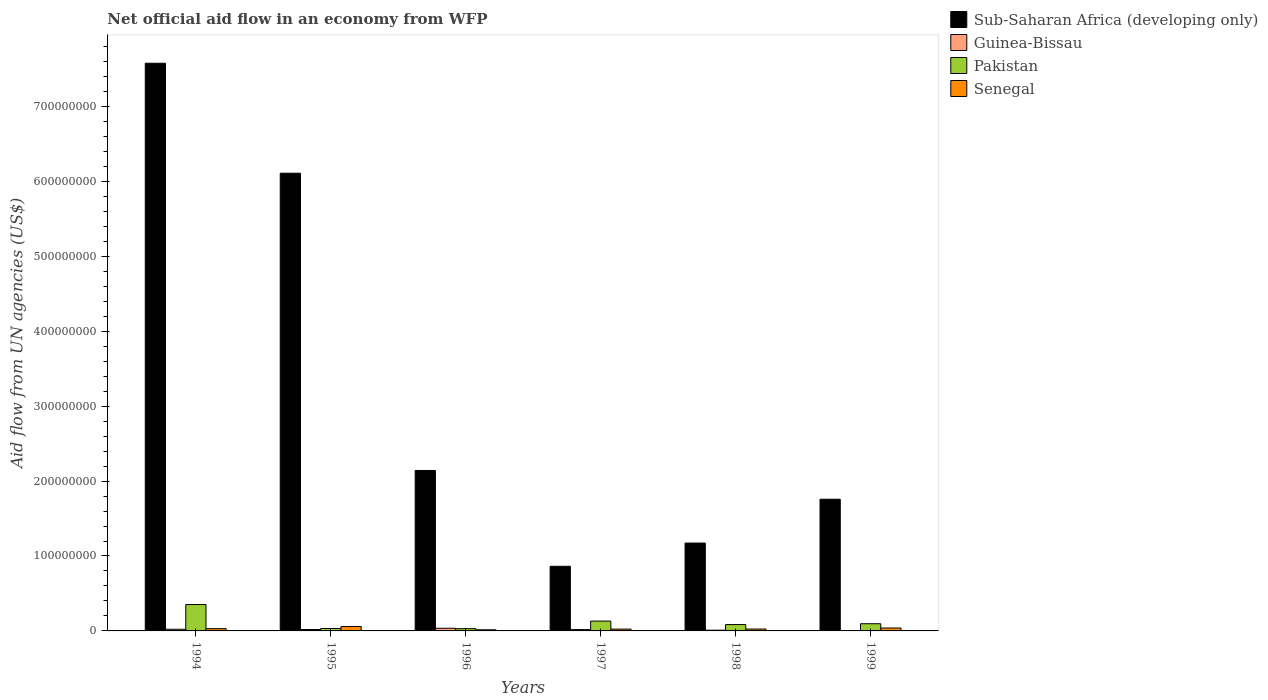How many different coloured bars are there?
Make the answer very short. 4. Are the number of bars per tick equal to the number of legend labels?
Your answer should be very brief. Yes. Are the number of bars on each tick of the X-axis equal?
Ensure brevity in your answer.  Yes. How many bars are there on the 6th tick from the right?
Keep it short and to the point. 4. In how many cases, is the number of bars for a given year not equal to the number of legend labels?
Offer a terse response. 0. What is the net official aid flow in Pakistan in 1998?
Your response must be concise. 8.47e+06. Across all years, what is the maximum net official aid flow in Senegal?
Your answer should be compact. 5.94e+06. Across all years, what is the minimum net official aid flow in Sub-Saharan Africa (developing only)?
Your answer should be compact. 8.63e+07. What is the total net official aid flow in Pakistan in the graph?
Give a very brief answer. 7.27e+07. What is the difference between the net official aid flow in Guinea-Bissau in 1996 and that in 1998?
Your response must be concise. 2.55e+06. What is the difference between the net official aid flow in Pakistan in 1999 and the net official aid flow in Senegal in 1996?
Your response must be concise. 8.10e+06. What is the average net official aid flow in Sub-Saharan Africa (developing only) per year?
Keep it short and to the point. 3.27e+08. In the year 1998, what is the difference between the net official aid flow in Guinea-Bissau and net official aid flow in Pakistan?
Ensure brevity in your answer.  -7.47e+06. In how many years, is the net official aid flow in Senegal greater than 500000000 US$?
Your response must be concise. 0. What is the ratio of the net official aid flow in Sub-Saharan Africa (developing only) in 1995 to that in 1996?
Your answer should be very brief. 2.85. Is the net official aid flow in Guinea-Bissau in 1997 less than that in 1998?
Offer a terse response. No. Is the difference between the net official aid flow in Guinea-Bissau in 1997 and 1999 greater than the difference between the net official aid flow in Pakistan in 1997 and 1999?
Ensure brevity in your answer.  No. What is the difference between the highest and the second highest net official aid flow in Pakistan?
Give a very brief answer. 2.21e+07. What is the difference between the highest and the lowest net official aid flow in Pakistan?
Make the answer very short. 3.22e+07. In how many years, is the net official aid flow in Pakistan greater than the average net official aid flow in Pakistan taken over all years?
Make the answer very short. 2. Is the sum of the net official aid flow in Sub-Saharan Africa (developing only) in 1995 and 1997 greater than the maximum net official aid flow in Senegal across all years?
Provide a succinct answer. Yes. What does the 4th bar from the left in 1995 represents?
Your response must be concise. Senegal. What does the 1st bar from the right in 1997 represents?
Ensure brevity in your answer.  Senegal. How many bars are there?
Provide a succinct answer. 24. Are the values on the major ticks of Y-axis written in scientific E-notation?
Your answer should be compact. No. How are the legend labels stacked?
Provide a short and direct response. Vertical. What is the title of the graph?
Provide a short and direct response. Net official aid flow in an economy from WFP. Does "Vanuatu" appear as one of the legend labels in the graph?
Offer a terse response. No. What is the label or title of the X-axis?
Ensure brevity in your answer.  Years. What is the label or title of the Y-axis?
Your response must be concise. Aid flow from UN agencies (US$). What is the Aid flow from UN agencies (US$) of Sub-Saharan Africa (developing only) in 1994?
Give a very brief answer. 7.58e+08. What is the Aid flow from UN agencies (US$) of Guinea-Bissau in 1994?
Provide a succinct answer. 2.22e+06. What is the Aid flow from UN agencies (US$) of Pakistan in 1994?
Provide a succinct answer. 3.52e+07. What is the Aid flow from UN agencies (US$) in Senegal in 1994?
Give a very brief answer. 3.02e+06. What is the Aid flow from UN agencies (US$) in Sub-Saharan Africa (developing only) in 1995?
Offer a terse response. 6.11e+08. What is the Aid flow from UN agencies (US$) of Guinea-Bissau in 1995?
Provide a short and direct response. 1.86e+06. What is the Aid flow from UN agencies (US$) in Pakistan in 1995?
Your answer should be compact. 3.25e+06. What is the Aid flow from UN agencies (US$) in Senegal in 1995?
Provide a succinct answer. 5.94e+06. What is the Aid flow from UN agencies (US$) in Sub-Saharan Africa (developing only) in 1996?
Your answer should be compact. 2.14e+08. What is the Aid flow from UN agencies (US$) in Guinea-Bissau in 1996?
Your answer should be very brief. 3.55e+06. What is the Aid flow from UN agencies (US$) of Pakistan in 1996?
Your response must be concise. 3.03e+06. What is the Aid flow from UN agencies (US$) of Senegal in 1996?
Offer a very short reply. 1.51e+06. What is the Aid flow from UN agencies (US$) in Sub-Saharan Africa (developing only) in 1997?
Offer a terse response. 8.63e+07. What is the Aid flow from UN agencies (US$) of Guinea-Bissau in 1997?
Provide a short and direct response. 1.79e+06. What is the Aid flow from UN agencies (US$) in Pakistan in 1997?
Provide a short and direct response. 1.31e+07. What is the Aid flow from UN agencies (US$) of Senegal in 1997?
Give a very brief answer. 2.42e+06. What is the Aid flow from UN agencies (US$) of Sub-Saharan Africa (developing only) in 1998?
Offer a terse response. 1.17e+08. What is the Aid flow from UN agencies (US$) of Guinea-Bissau in 1998?
Your answer should be compact. 1.00e+06. What is the Aid flow from UN agencies (US$) of Pakistan in 1998?
Ensure brevity in your answer.  8.47e+06. What is the Aid flow from UN agencies (US$) in Senegal in 1998?
Offer a very short reply. 2.50e+06. What is the Aid flow from UN agencies (US$) of Sub-Saharan Africa (developing only) in 1999?
Offer a terse response. 1.76e+08. What is the Aid flow from UN agencies (US$) in Guinea-Bissau in 1999?
Ensure brevity in your answer.  4.50e+05. What is the Aid flow from UN agencies (US$) in Pakistan in 1999?
Your answer should be very brief. 9.61e+06. What is the Aid flow from UN agencies (US$) in Senegal in 1999?
Provide a succinct answer. 3.88e+06. Across all years, what is the maximum Aid flow from UN agencies (US$) of Sub-Saharan Africa (developing only)?
Offer a terse response. 7.58e+08. Across all years, what is the maximum Aid flow from UN agencies (US$) in Guinea-Bissau?
Provide a succinct answer. 3.55e+06. Across all years, what is the maximum Aid flow from UN agencies (US$) in Pakistan?
Give a very brief answer. 3.52e+07. Across all years, what is the maximum Aid flow from UN agencies (US$) of Senegal?
Provide a short and direct response. 5.94e+06. Across all years, what is the minimum Aid flow from UN agencies (US$) of Sub-Saharan Africa (developing only)?
Give a very brief answer. 8.63e+07. Across all years, what is the minimum Aid flow from UN agencies (US$) of Pakistan?
Make the answer very short. 3.03e+06. Across all years, what is the minimum Aid flow from UN agencies (US$) of Senegal?
Offer a terse response. 1.51e+06. What is the total Aid flow from UN agencies (US$) in Sub-Saharan Africa (developing only) in the graph?
Your response must be concise. 1.96e+09. What is the total Aid flow from UN agencies (US$) of Guinea-Bissau in the graph?
Your answer should be compact. 1.09e+07. What is the total Aid flow from UN agencies (US$) in Pakistan in the graph?
Offer a terse response. 7.27e+07. What is the total Aid flow from UN agencies (US$) of Senegal in the graph?
Provide a succinct answer. 1.93e+07. What is the difference between the Aid flow from UN agencies (US$) in Sub-Saharan Africa (developing only) in 1994 and that in 1995?
Ensure brevity in your answer.  1.47e+08. What is the difference between the Aid flow from UN agencies (US$) in Guinea-Bissau in 1994 and that in 1995?
Your answer should be compact. 3.60e+05. What is the difference between the Aid flow from UN agencies (US$) in Pakistan in 1994 and that in 1995?
Keep it short and to the point. 3.20e+07. What is the difference between the Aid flow from UN agencies (US$) of Senegal in 1994 and that in 1995?
Offer a terse response. -2.92e+06. What is the difference between the Aid flow from UN agencies (US$) of Sub-Saharan Africa (developing only) in 1994 and that in 1996?
Your answer should be compact. 5.44e+08. What is the difference between the Aid flow from UN agencies (US$) in Guinea-Bissau in 1994 and that in 1996?
Keep it short and to the point. -1.33e+06. What is the difference between the Aid flow from UN agencies (US$) of Pakistan in 1994 and that in 1996?
Offer a terse response. 3.22e+07. What is the difference between the Aid flow from UN agencies (US$) of Senegal in 1994 and that in 1996?
Make the answer very short. 1.51e+06. What is the difference between the Aid flow from UN agencies (US$) of Sub-Saharan Africa (developing only) in 1994 and that in 1997?
Your answer should be compact. 6.71e+08. What is the difference between the Aid flow from UN agencies (US$) in Guinea-Bissau in 1994 and that in 1997?
Ensure brevity in your answer.  4.30e+05. What is the difference between the Aid flow from UN agencies (US$) in Pakistan in 1994 and that in 1997?
Keep it short and to the point. 2.21e+07. What is the difference between the Aid flow from UN agencies (US$) in Sub-Saharan Africa (developing only) in 1994 and that in 1998?
Keep it short and to the point. 6.40e+08. What is the difference between the Aid flow from UN agencies (US$) in Guinea-Bissau in 1994 and that in 1998?
Your answer should be very brief. 1.22e+06. What is the difference between the Aid flow from UN agencies (US$) of Pakistan in 1994 and that in 1998?
Ensure brevity in your answer.  2.68e+07. What is the difference between the Aid flow from UN agencies (US$) in Senegal in 1994 and that in 1998?
Ensure brevity in your answer.  5.20e+05. What is the difference between the Aid flow from UN agencies (US$) of Sub-Saharan Africa (developing only) in 1994 and that in 1999?
Ensure brevity in your answer.  5.82e+08. What is the difference between the Aid flow from UN agencies (US$) in Guinea-Bissau in 1994 and that in 1999?
Your answer should be very brief. 1.77e+06. What is the difference between the Aid flow from UN agencies (US$) in Pakistan in 1994 and that in 1999?
Provide a short and direct response. 2.56e+07. What is the difference between the Aid flow from UN agencies (US$) of Senegal in 1994 and that in 1999?
Give a very brief answer. -8.60e+05. What is the difference between the Aid flow from UN agencies (US$) of Sub-Saharan Africa (developing only) in 1995 and that in 1996?
Ensure brevity in your answer.  3.97e+08. What is the difference between the Aid flow from UN agencies (US$) in Guinea-Bissau in 1995 and that in 1996?
Make the answer very short. -1.69e+06. What is the difference between the Aid flow from UN agencies (US$) in Senegal in 1995 and that in 1996?
Keep it short and to the point. 4.43e+06. What is the difference between the Aid flow from UN agencies (US$) of Sub-Saharan Africa (developing only) in 1995 and that in 1997?
Offer a very short reply. 5.25e+08. What is the difference between the Aid flow from UN agencies (US$) in Pakistan in 1995 and that in 1997?
Offer a terse response. -9.88e+06. What is the difference between the Aid flow from UN agencies (US$) in Senegal in 1995 and that in 1997?
Your answer should be compact. 3.52e+06. What is the difference between the Aid flow from UN agencies (US$) of Sub-Saharan Africa (developing only) in 1995 and that in 1998?
Ensure brevity in your answer.  4.94e+08. What is the difference between the Aid flow from UN agencies (US$) in Guinea-Bissau in 1995 and that in 1998?
Your answer should be compact. 8.60e+05. What is the difference between the Aid flow from UN agencies (US$) of Pakistan in 1995 and that in 1998?
Make the answer very short. -5.22e+06. What is the difference between the Aid flow from UN agencies (US$) of Senegal in 1995 and that in 1998?
Keep it short and to the point. 3.44e+06. What is the difference between the Aid flow from UN agencies (US$) of Sub-Saharan Africa (developing only) in 1995 and that in 1999?
Your response must be concise. 4.35e+08. What is the difference between the Aid flow from UN agencies (US$) in Guinea-Bissau in 1995 and that in 1999?
Give a very brief answer. 1.41e+06. What is the difference between the Aid flow from UN agencies (US$) of Pakistan in 1995 and that in 1999?
Your answer should be very brief. -6.36e+06. What is the difference between the Aid flow from UN agencies (US$) in Senegal in 1995 and that in 1999?
Your answer should be very brief. 2.06e+06. What is the difference between the Aid flow from UN agencies (US$) in Sub-Saharan Africa (developing only) in 1996 and that in 1997?
Give a very brief answer. 1.28e+08. What is the difference between the Aid flow from UN agencies (US$) of Guinea-Bissau in 1996 and that in 1997?
Your answer should be very brief. 1.76e+06. What is the difference between the Aid flow from UN agencies (US$) of Pakistan in 1996 and that in 1997?
Give a very brief answer. -1.01e+07. What is the difference between the Aid flow from UN agencies (US$) in Senegal in 1996 and that in 1997?
Keep it short and to the point. -9.10e+05. What is the difference between the Aid flow from UN agencies (US$) of Sub-Saharan Africa (developing only) in 1996 and that in 1998?
Give a very brief answer. 9.69e+07. What is the difference between the Aid flow from UN agencies (US$) in Guinea-Bissau in 1996 and that in 1998?
Provide a succinct answer. 2.55e+06. What is the difference between the Aid flow from UN agencies (US$) in Pakistan in 1996 and that in 1998?
Ensure brevity in your answer.  -5.44e+06. What is the difference between the Aid flow from UN agencies (US$) in Senegal in 1996 and that in 1998?
Provide a short and direct response. -9.90e+05. What is the difference between the Aid flow from UN agencies (US$) in Sub-Saharan Africa (developing only) in 1996 and that in 1999?
Your response must be concise. 3.84e+07. What is the difference between the Aid flow from UN agencies (US$) in Guinea-Bissau in 1996 and that in 1999?
Give a very brief answer. 3.10e+06. What is the difference between the Aid flow from UN agencies (US$) of Pakistan in 1996 and that in 1999?
Your answer should be very brief. -6.58e+06. What is the difference between the Aid flow from UN agencies (US$) of Senegal in 1996 and that in 1999?
Offer a very short reply. -2.37e+06. What is the difference between the Aid flow from UN agencies (US$) in Sub-Saharan Africa (developing only) in 1997 and that in 1998?
Your answer should be very brief. -3.10e+07. What is the difference between the Aid flow from UN agencies (US$) of Guinea-Bissau in 1997 and that in 1998?
Your response must be concise. 7.90e+05. What is the difference between the Aid flow from UN agencies (US$) of Pakistan in 1997 and that in 1998?
Your answer should be very brief. 4.66e+06. What is the difference between the Aid flow from UN agencies (US$) in Sub-Saharan Africa (developing only) in 1997 and that in 1999?
Keep it short and to the point. -8.95e+07. What is the difference between the Aid flow from UN agencies (US$) in Guinea-Bissau in 1997 and that in 1999?
Your answer should be very brief. 1.34e+06. What is the difference between the Aid flow from UN agencies (US$) of Pakistan in 1997 and that in 1999?
Offer a terse response. 3.52e+06. What is the difference between the Aid flow from UN agencies (US$) in Senegal in 1997 and that in 1999?
Keep it short and to the point. -1.46e+06. What is the difference between the Aid flow from UN agencies (US$) of Sub-Saharan Africa (developing only) in 1998 and that in 1999?
Provide a short and direct response. -5.85e+07. What is the difference between the Aid flow from UN agencies (US$) in Guinea-Bissau in 1998 and that in 1999?
Your answer should be very brief. 5.50e+05. What is the difference between the Aid flow from UN agencies (US$) of Pakistan in 1998 and that in 1999?
Provide a short and direct response. -1.14e+06. What is the difference between the Aid flow from UN agencies (US$) in Senegal in 1998 and that in 1999?
Keep it short and to the point. -1.38e+06. What is the difference between the Aid flow from UN agencies (US$) in Sub-Saharan Africa (developing only) in 1994 and the Aid flow from UN agencies (US$) in Guinea-Bissau in 1995?
Ensure brevity in your answer.  7.56e+08. What is the difference between the Aid flow from UN agencies (US$) in Sub-Saharan Africa (developing only) in 1994 and the Aid flow from UN agencies (US$) in Pakistan in 1995?
Make the answer very short. 7.54e+08. What is the difference between the Aid flow from UN agencies (US$) in Sub-Saharan Africa (developing only) in 1994 and the Aid flow from UN agencies (US$) in Senegal in 1995?
Give a very brief answer. 7.52e+08. What is the difference between the Aid flow from UN agencies (US$) of Guinea-Bissau in 1994 and the Aid flow from UN agencies (US$) of Pakistan in 1995?
Offer a very short reply. -1.03e+06. What is the difference between the Aid flow from UN agencies (US$) of Guinea-Bissau in 1994 and the Aid flow from UN agencies (US$) of Senegal in 1995?
Offer a very short reply. -3.72e+06. What is the difference between the Aid flow from UN agencies (US$) of Pakistan in 1994 and the Aid flow from UN agencies (US$) of Senegal in 1995?
Provide a succinct answer. 2.93e+07. What is the difference between the Aid flow from UN agencies (US$) of Sub-Saharan Africa (developing only) in 1994 and the Aid flow from UN agencies (US$) of Guinea-Bissau in 1996?
Provide a succinct answer. 7.54e+08. What is the difference between the Aid flow from UN agencies (US$) of Sub-Saharan Africa (developing only) in 1994 and the Aid flow from UN agencies (US$) of Pakistan in 1996?
Give a very brief answer. 7.55e+08. What is the difference between the Aid flow from UN agencies (US$) of Sub-Saharan Africa (developing only) in 1994 and the Aid flow from UN agencies (US$) of Senegal in 1996?
Keep it short and to the point. 7.56e+08. What is the difference between the Aid flow from UN agencies (US$) in Guinea-Bissau in 1994 and the Aid flow from UN agencies (US$) in Pakistan in 1996?
Offer a very short reply. -8.10e+05. What is the difference between the Aid flow from UN agencies (US$) of Guinea-Bissau in 1994 and the Aid flow from UN agencies (US$) of Senegal in 1996?
Ensure brevity in your answer.  7.10e+05. What is the difference between the Aid flow from UN agencies (US$) in Pakistan in 1994 and the Aid flow from UN agencies (US$) in Senegal in 1996?
Your answer should be very brief. 3.37e+07. What is the difference between the Aid flow from UN agencies (US$) in Sub-Saharan Africa (developing only) in 1994 and the Aid flow from UN agencies (US$) in Guinea-Bissau in 1997?
Provide a succinct answer. 7.56e+08. What is the difference between the Aid flow from UN agencies (US$) in Sub-Saharan Africa (developing only) in 1994 and the Aid flow from UN agencies (US$) in Pakistan in 1997?
Your answer should be very brief. 7.45e+08. What is the difference between the Aid flow from UN agencies (US$) in Sub-Saharan Africa (developing only) in 1994 and the Aid flow from UN agencies (US$) in Senegal in 1997?
Provide a short and direct response. 7.55e+08. What is the difference between the Aid flow from UN agencies (US$) in Guinea-Bissau in 1994 and the Aid flow from UN agencies (US$) in Pakistan in 1997?
Ensure brevity in your answer.  -1.09e+07. What is the difference between the Aid flow from UN agencies (US$) of Pakistan in 1994 and the Aid flow from UN agencies (US$) of Senegal in 1997?
Your answer should be very brief. 3.28e+07. What is the difference between the Aid flow from UN agencies (US$) of Sub-Saharan Africa (developing only) in 1994 and the Aid flow from UN agencies (US$) of Guinea-Bissau in 1998?
Offer a very short reply. 7.57e+08. What is the difference between the Aid flow from UN agencies (US$) of Sub-Saharan Africa (developing only) in 1994 and the Aid flow from UN agencies (US$) of Pakistan in 1998?
Your answer should be compact. 7.49e+08. What is the difference between the Aid flow from UN agencies (US$) in Sub-Saharan Africa (developing only) in 1994 and the Aid flow from UN agencies (US$) in Senegal in 1998?
Make the answer very short. 7.55e+08. What is the difference between the Aid flow from UN agencies (US$) in Guinea-Bissau in 1994 and the Aid flow from UN agencies (US$) in Pakistan in 1998?
Provide a succinct answer. -6.25e+06. What is the difference between the Aid flow from UN agencies (US$) of Guinea-Bissau in 1994 and the Aid flow from UN agencies (US$) of Senegal in 1998?
Your answer should be very brief. -2.80e+05. What is the difference between the Aid flow from UN agencies (US$) in Pakistan in 1994 and the Aid flow from UN agencies (US$) in Senegal in 1998?
Give a very brief answer. 3.27e+07. What is the difference between the Aid flow from UN agencies (US$) in Sub-Saharan Africa (developing only) in 1994 and the Aid flow from UN agencies (US$) in Guinea-Bissau in 1999?
Ensure brevity in your answer.  7.57e+08. What is the difference between the Aid flow from UN agencies (US$) in Sub-Saharan Africa (developing only) in 1994 and the Aid flow from UN agencies (US$) in Pakistan in 1999?
Offer a terse response. 7.48e+08. What is the difference between the Aid flow from UN agencies (US$) of Sub-Saharan Africa (developing only) in 1994 and the Aid flow from UN agencies (US$) of Senegal in 1999?
Keep it short and to the point. 7.54e+08. What is the difference between the Aid flow from UN agencies (US$) of Guinea-Bissau in 1994 and the Aid flow from UN agencies (US$) of Pakistan in 1999?
Provide a succinct answer. -7.39e+06. What is the difference between the Aid flow from UN agencies (US$) in Guinea-Bissau in 1994 and the Aid flow from UN agencies (US$) in Senegal in 1999?
Your answer should be compact. -1.66e+06. What is the difference between the Aid flow from UN agencies (US$) of Pakistan in 1994 and the Aid flow from UN agencies (US$) of Senegal in 1999?
Give a very brief answer. 3.14e+07. What is the difference between the Aid flow from UN agencies (US$) in Sub-Saharan Africa (developing only) in 1995 and the Aid flow from UN agencies (US$) in Guinea-Bissau in 1996?
Your response must be concise. 6.07e+08. What is the difference between the Aid flow from UN agencies (US$) in Sub-Saharan Africa (developing only) in 1995 and the Aid flow from UN agencies (US$) in Pakistan in 1996?
Offer a terse response. 6.08e+08. What is the difference between the Aid flow from UN agencies (US$) of Sub-Saharan Africa (developing only) in 1995 and the Aid flow from UN agencies (US$) of Senegal in 1996?
Keep it short and to the point. 6.09e+08. What is the difference between the Aid flow from UN agencies (US$) in Guinea-Bissau in 1995 and the Aid flow from UN agencies (US$) in Pakistan in 1996?
Give a very brief answer. -1.17e+06. What is the difference between the Aid flow from UN agencies (US$) in Pakistan in 1995 and the Aid flow from UN agencies (US$) in Senegal in 1996?
Offer a very short reply. 1.74e+06. What is the difference between the Aid flow from UN agencies (US$) in Sub-Saharan Africa (developing only) in 1995 and the Aid flow from UN agencies (US$) in Guinea-Bissau in 1997?
Give a very brief answer. 6.09e+08. What is the difference between the Aid flow from UN agencies (US$) in Sub-Saharan Africa (developing only) in 1995 and the Aid flow from UN agencies (US$) in Pakistan in 1997?
Offer a very short reply. 5.98e+08. What is the difference between the Aid flow from UN agencies (US$) in Sub-Saharan Africa (developing only) in 1995 and the Aid flow from UN agencies (US$) in Senegal in 1997?
Your response must be concise. 6.08e+08. What is the difference between the Aid flow from UN agencies (US$) in Guinea-Bissau in 1995 and the Aid flow from UN agencies (US$) in Pakistan in 1997?
Offer a very short reply. -1.13e+07. What is the difference between the Aid flow from UN agencies (US$) in Guinea-Bissau in 1995 and the Aid flow from UN agencies (US$) in Senegal in 1997?
Provide a short and direct response. -5.60e+05. What is the difference between the Aid flow from UN agencies (US$) in Pakistan in 1995 and the Aid flow from UN agencies (US$) in Senegal in 1997?
Provide a short and direct response. 8.30e+05. What is the difference between the Aid flow from UN agencies (US$) of Sub-Saharan Africa (developing only) in 1995 and the Aid flow from UN agencies (US$) of Guinea-Bissau in 1998?
Make the answer very short. 6.10e+08. What is the difference between the Aid flow from UN agencies (US$) in Sub-Saharan Africa (developing only) in 1995 and the Aid flow from UN agencies (US$) in Pakistan in 1998?
Offer a very short reply. 6.02e+08. What is the difference between the Aid flow from UN agencies (US$) in Sub-Saharan Africa (developing only) in 1995 and the Aid flow from UN agencies (US$) in Senegal in 1998?
Ensure brevity in your answer.  6.08e+08. What is the difference between the Aid flow from UN agencies (US$) of Guinea-Bissau in 1995 and the Aid flow from UN agencies (US$) of Pakistan in 1998?
Offer a terse response. -6.61e+06. What is the difference between the Aid flow from UN agencies (US$) of Guinea-Bissau in 1995 and the Aid flow from UN agencies (US$) of Senegal in 1998?
Ensure brevity in your answer.  -6.40e+05. What is the difference between the Aid flow from UN agencies (US$) in Pakistan in 1995 and the Aid flow from UN agencies (US$) in Senegal in 1998?
Your response must be concise. 7.50e+05. What is the difference between the Aid flow from UN agencies (US$) of Sub-Saharan Africa (developing only) in 1995 and the Aid flow from UN agencies (US$) of Guinea-Bissau in 1999?
Ensure brevity in your answer.  6.10e+08. What is the difference between the Aid flow from UN agencies (US$) of Sub-Saharan Africa (developing only) in 1995 and the Aid flow from UN agencies (US$) of Pakistan in 1999?
Offer a very short reply. 6.01e+08. What is the difference between the Aid flow from UN agencies (US$) in Sub-Saharan Africa (developing only) in 1995 and the Aid flow from UN agencies (US$) in Senegal in 1999?
Give a very brief answer. 6.07e+08. What is the difference between the Aid flow from UN agencies (US$) of Guinea-Bissau in 1995 and the Aid flow from UN agencies (US$) of Pakistan in 1999?
Provide a succinct answer. -7.75e+06. What is the difference between the Aid flow from UN agencies (US$) in Guinea-Bissau in 1995 and the Aid flow from UN agencies (US$) in Senegal in 1999?
Provide a short and direct response. -2.02e+06. What is the difference between the Aid flow from UN agencies (US$) of Pakistan in 1995 and the Aid flow from UN agencies (US$) of Senegal in 1999?
Your answer should be compact. -6.30e+05. What is the difference between the Aid flow from UN agencies (US$) of Sub-Saharan Africa (developing only) in 1996 and the Aid flow from UN agencies (US$) of Guinea-Bissau in 1997?
Your answer should be very brief. 2.12e+08. What is the difference between the Aid flow from UN agencies (US$) of Sub-Saharan Africa (developing only) in 1996 and the Aid flow from UN agencies (US$) of Pakistan in 1997?
Offer a terse response. 2.01e+08. What is the difference between the Aid flow from UN agencies (US$) of Sub-Saharan Africa (developing only) in 1996 and the Aid flow from UN agencies (US$) of Senegal in 1997?
Offer a very short reply. 2.12e+08. What is the difference between the Aid flow from UN agencies (US$) of Guinea-Bissau in 1996 and the Aid flow from UN agencies (US$) of Pakistan in 1997?
Provide a short and direct response. -9.58e+06. What is the difference between the Aid flow from UN agencies (US$) of Guinea-Bissau in 1996 and the Aid flow from UN agencies (US$) of Senegal in 1997?
Keep it short and to the point. 1.13e+06. What is the difference between the Aid flow from UN agencies (US$) in Sub-Saharan Africa (developing only) in 1996 and the Aid flow from UN agencies (US$) in Guinea-Bissau in 1998?
Offer a very short reply. 2.13e+08. What is the difference between the Aid flow from UN agencies (US$) of Sub-Saharan Africa (developing only) in 1996 and the Aid flow from UN agencies (US$) of Pakistan in 1998?
Provide a short and direct response. 2.06e+08. What is the difference between the Aid flow from UN agencies (US$) of Sub-Saharan Africa (developing only) in 1996 and the Aid flow from UN agencies (US$) of Senegal in 1998?
Offer a very short reply. 2.12e+08. What is the difference between the Aid flow from UN agencies (US$) in Guinea-Bissau in 1996 and the Aid flow from UN agencies (US$) in Pakistan in 1998?
Provide a short and direct response. -4.92e+06. What is the difference between the Aid flow from UN agencies (US$) of Guinea-Bissau in 1996 and the Aid flow from UN agencies (US$) of Senegal in 1998?
Keep it short and to the point. 1.05e+06. What is the difference between the Aid flow from UN agencies (US$) of Pakistan in 1996 and the Aid flow from UN agencies (US$) of Senegal in 1998?
Your answer should be very brief. 5.30e+05. What is the difference between the Aid flow from UN agencies (US$) of Sub-Saharan Africa (developing only) in 1996 and the Aid flow from UN agencies (US$) of Guinea-Bissau in 1999?
Provide a short and direct response. 2.14e+08. What is the difference between the Aid flow from UN agencies (US$) in Sub-Saharan Africa (developing only) in 1996 and the Aid flow from UN agencies (US$) in Pakistan in 1999?
Your answer should be compact. 2.05e+08. What is the difference between the Aid flow from UN agencies (US$) in Sub-Saharan Africa (developing only) in 1996 and the Aid flow from UN agencies (US$) in Senegal in 1999?
Provide a short and direct response. 2.10e+08. What is the difference between the Aid flow from UN agencies (US$) in Guinea-Bissau in 1996 and the Aid flow from UN agencies (US$) in Pakistan in 1999?
Provide a short and direct response. -6.06e+06. What is the difference between the Aid flow from UN agencies (US$) in Guinea-Bissau in 1996 and the Aid flow from UN agencies (US$) in Senegal in 1999?
Provide a short and direct response. -3.30e+05. What is the difference between the Aid flow from UN agencies (US$) in Pakistan in 1996 and the Aid flow from UN agencies (US$) in Senegal in 1999?
Offer a very short reply. -8.50e+05. What is the difference between the Aid flow from UN agencies (US$) of Sub-Saharan Africa (developing only) in 1997 and the Aid flow from UN agencies (US$) of Guinea-Bissau in 1998?
Make the answer very short. 8.53e+07. What is the difference between the Aid flow from UN agencies (US$) of Sub-Saharan Africa (developing only) in 1997 and the Aid flow from UN agencies (US$) of Pakistan in 1998?
Give a very brief answer. 7.78e+07. What is the difference between the Aid flow from UN agencies (US$) of Sub-Saharan Africa (developing only) in 1997 and the Aid flow from UN agencies (US$) of Senegal in 1998?
Your answer should be compact. 8.38e+07. What is the difference between the Aid flow from UN agencies (US$) in Guinea-Bissau in 1997 and the Aid flow from UN agencies (US$) in Pakistan in 1998?
Offer a terse response. -6.68e+06. What is the difference between the Aid flow from UN agencies (US$) of Guinea-Bissau in 1997 and the Aid flow from UN agencies (US$) of Senegal in 1998?
Offer a terse response. -7.10e+05. What is the difference between the Aid flow from UN agencies (US$) in Pakistan in 1997 and the Aid flow from UN agencies (US$) in Senegal in 1998?
Offer a terse response. 1.06e+07. What is the difference between the Aid flow from UN agencies (US$) of Sub-Saharan Africa (developing only) in 1997 and the Aid flow from UN agencies (US$) of Guinea-Bissau in 1999?
Your answer should be compact. 8.58e+07. What is the difference between the Aid flow from UN agencies (US$) in Sub-Saharan Africa (developing only) in 1997 and the Aid flow from UN agencies (US$) in Pakistan in 1999?
Your answer should be very brief. 7.66e+07. What is the difference between the Aid flow from UN agencies (US$) in Sub-Saharan Africa (developing only) in 1997 and the Aid flow from UN agencies (US$) in Senegal in 1999?
Offer a very short reply. 8.24e+07. What is the difference between the Aid flow from UN agencies (US$) of Guinea-Bissau in 1997 and the Aid flow from UN agencies (US$) of Pakistan in 1999?
Provide a succinct answer. -7.82e+06. What is the difference between the Aid flow from UN agencies (US$) in Guinea-Bissau in 1997 and the Aid flow from UN agencies (US$) in Senegal in 1999?
Your response must be concise. -2.09e+06. What is the difference between the Aid flow from UN agencies (US$) in Pakistan in 1997 and the Aid flow from UN agencies (US$) in Senegal in 1999?
Provide a short and direct response. 9.25e+06. What is the difference between the Aid flow from UN agencies (US$) of Sub-Saharan Africa (developing only) in 1998 and the Aid flow from UN agencies (US$) of Guinea-Bissau in 1999?
Ensure brevity in your answer.  1.17e+08. What is the difference between the Aid flow from UN agencies (US$) of Sub-Saharan Africa (developing only) in 1998 and the Aid flow from UN agencies (US$) of Pakistan in 1999?
Make the answer very short. 1.08e+08. What is the difference between the Aid flow from UN agencies (US$) in Sub-Saharan Africa (developing only) in 1998 and the Aid flow from UN agencies (US$) in Senegal in 1999?
Offer a terse response. 1.13e+08. What is the difference between the Aid flow from UN agencies (US$) in Guinea-Bissau in 1998 and the Aid flow from UN agencies (US$) in Pakistan in 1999?
Offer a terse response. -8.61e+06. What is the difference between the Aid flow from UN agencies (US$) of Guinea-Bissau in 1998 and the Aid flow from UN agencies (US$) of Senegal in 1999?
Offer a very short reply. -2.88e+06. What is the difference between the Aid flow from UN agencies (US$) in Pakistan in 1998 and the Aid flow from UN agencies (US$) in Senegal in 1999?
Give a very brief answer. 4.59e+06. What is the average Aid flow from UN agencies (US$) in Sub-Saharan Africa (developing only) per year?
Provide a short and direct response. 3.27e+08. What is the average Aid flow from UN agencies (US$) of Guinea-Bissau per year?
Offer a terse response. 1.81e+06. What is the average Aid flow from UN agencies (US$) in Pakistan per year?
Give a very brief answer. 1.21e+07. What is the average Aid flow from UN agencies (US$) of Senegal per year?
Your answer should be compact. 3.21e+06. In the year 1994, what is the difference between the Aid flow from UN agencies (US$) in Sub-Saharan Africa (developing only) and Aid flow from UN agencies (US$) in Guinea-Bissau?
Your response must be concise. 7.55e+08. In the year 1994, what is the difference between the Aid flow from UN agencies (US$) of Sub-Saharan Africa (developing only) and Aid flow from UN agencies (US$) of Pakistan?
Your answer should be very brief. 7.22e+08. In the year 1994, what is the difference between the Aid flow from UN agencies (US$) in Sub-Saharan Africa (developing only) and Aid flow from UN agencies (US$) in Senegal?
Keep it short and to the point. 7.55e+08. In the year 1994, what is the difference between the Aid flow from UN agencies (US$) in Guinea-Bissau and Aid flow from UN agencies (US$) in Pakistan?
Make the answer very short. -3.30e+07. In the year 1994, what is the difference between the Aid flow from UN agencies (US$) in Guinea-Bissau and Aid flow from UN agencies (US$) in Senegal?
Your answer should be compact. -8.00e+05. In the year 1994, what is the difference between the Aid flow from UN agencies (US$) in Pakistan and Aid flow from UN agencies (US$) in Senegal?
Your response must be concise. 3.22e+07. In the year 1995, what is the difference between the Aid flow from UN agencies (US$) of Sub-Saharan Africa (developing only) and Aid flow from UN agencies (US$) of Guinea-Bissau?
Offer a terse response. 6.09e+08. In the year 1995, what is the difference between the Aid flow from UN agencies (US$) of Sub-Saharan Africa (developing only) and Aid flow from UN agencies (US$) of Pakistan?
Your answer should be compact. 6.08e+08. In the year 1995, what is the difference between the Aid flow from UN agencies (US$) in Sub-Saharan Africa (developing only) and Aid flow from UN agencies (US$) in Senegal?
Keep it short and to the point. 6.05e+08. In the year 1995, what is the difference between the Aid flow from UN agencies (US$) of Guinea-Bissau and Aid flow from UN agencies (US$) of Pakistan?
Ensure brevity in your answer.  -1.39e+06. In the year 1995, what is the difference between the Aid flow from UN agencies (US$) of Guinea-Bissau and Aid flow from UN agencies (US$) of Senegal?
Provide a short and direct response. -4.08e+06. In the year 1995, what is the difference between the Aid flow from UN agencies (US$) of Pakistan and Aid flow from UN agencies (US$) of Senegal?
Make the answer very short. -2.69e+06. In the year 1996, what is the difference between the Aid flow from UN agencies (US$) in Sub-Saharan Africa (developing only) and Aid flow from UN agencies (US$) in Guinea-Bissau?
Your answer should be compact. 2.11e+08. In the year 1996, what is the difference between the Aid flow from UN agencies (US$) of Sub-Saharan Africa (developing only) and Aid flow from UN agencies (US$) of Pakistan?
Your response must be concise. 2.11e+08. In the year 1996, what is the difference between the Aid flow from UN agencies (US$) of Sub-Saharan Africa (developing only) and Aid flow from UN agencies (US$) of Senegal?
Give a very brief answer. 2.13e+08. In the year 1996, what is the difference between the Aid flow from UN agencies (US$) in Guinea-Bissau and Aid flow from UN agencies (US$) in Pakistan?
Offer a terse response. 5.20e+05. In the year 1996, what is the difference between the Aid flow from UN agencies (US$) of Guinea-Bissau and Aid flow from UN agencies (US$) of Senegal?
Offer a very short reply. 2.04e+06. In the year 1996, what is the difference between the Aid flow from UN agencies (US$) of Pakistan and Aid flow from UN agencies (US$) of Senegal?
Your answer should be very brief. 1.52e+06. In the year 1997, what is the difference between the Aid flow from UN agencies (US$) in Sub-Saharan Africa (developing only) and Aid flow from UN agencies (US$) in Guinea-Bissau?
Provide a short and direct response. 8.45e+07. In the year 1997, what is the difference between the Aid flow from UN agencies (US$) of Sub-Saharan Africa (developing only) and Aid flow from UN agencies (US$) of Pakistan?
Provide a short and direct response. 7.31e+07. In the year 1997, what is the difference between the Aid flow from UN agencies (US$) in Sub-Saharan Africa (developing only) and Aid flow from UN agencies (US$) in Senegal?
Offer a terse response. 8.38e+07. In the year 1997, what is the difference between the Aid flow from UN agencies (US$) of Guinea-Bissau and Aid flow from UN agencies (US$) of Pakistan?
Ensure brevity in your answer.  -1.13e+07. In the year 1997, what is the difference between the Aid flow from UN agencies (US$) of Guinea-Bissau and Aid flow from UN agencies (US$) of Senegal?
Provide a succinct answer. -6.30e+05. In the year 1997, what is the difference between the Aid flow from UN agencies (US$) in Pakistan and Aid flow from UN agencies (US$) in Senegal?
Make the answer very short. 1.07e+07. In the year 1998, what is the difference between the Aid flow from UN agencies (US$) in Sub-Saharan Africa (developing only) and Aid flow from UN agencies (US$) in Guinea-Bissau?
Ensure brevity in your answer.  1.16e+08. In the year 1998, what is the difference between the Aid flow from UN agencies (US$) in Sub-Saharan Africa (developing only) and Aid flow from UN agencies (US$) in Pakistan?
Give a very brief answer. 1.09e+08. In the year 1998, what is the difference between the Aid flow from UN agencies (US$) in Sub-Saharan Africa (developing only) and Aid flow from UN agencies (US$) in Senegal?
Provide a short and direct response. 1.15e+08. In the year 1998, what is the difference between the Aid flow from UN agencies (US$) of Guinea-Bissau and Aid flow from UN agencies (US$) of Pakistan?
Your answer should be very brief. -7.47e+06. In the year 1998, what is the difference between the Aid flow from UN agencies (US$) of Guinea-Bissau and Aid flow from UN agencies (US$) of Senegal?
Provide a succinct answer. -1.50e+06. In the year 1998, what is the difference between the Aid flow from UN agencies (US$) of Pakistan and Aid flow from UN agencies (US$) of Senegal?
Provide a succinct answer. 5.97e+06. In the year 1999, what is the difference between the Aid flow from UN agencies (US$) in Sub-Saharan Africa (developing only) and Aid flow from UN agencies (US$) in Guinea-Bissau?
Provide a succinct answer. 1.75e+08. In the year 1999, what is the difference between the Aid flow from UN agencies (US$) of Sub-Saharan Africa (developing only) and Aid flow from UN agencies (US$) of Pakistan?
Your answer should be very brief. 1.66e+08. In the year 1999, what is the difference between the Aid flow from UN agencies (US$) in Sub-Saharan Africa (developing only) and Aid flow from UN agencies (US$) in Senegal?
Your answer should be compact. 1.72e+08. In the year 1999, what is the difference between the Aid flow from UN agencies (US$) in Guinea-Bissau and Aid flow from UN agencies (US$) in Pakistan?
Your answer should be very brief. -9.16e+06. In the year 1999, what is the difference between the Aid flow from UN agencies (US$) in Guinea-Bissau and Aid flow from UN agencies (US$) in Senegal?
Ensure brevity in your answer.  -3.43e+06. In the year 1999, what is the difference between the Aid flow from UN agencies (US$) in Pakistan and Aid flow from UN agencies (US$) in Senegal?
Your answer should be very brief. 5.73e+06. What is the ratio of the Aid flow from UN agencies (US$) in Sub-Saharan Africa (developing only) in 1994 to that in 1995?
Your response must be concise. 1.24. What is the ratio of the Aid flow from UN agencies (US$) of Guinea-Bissau in 1994 to that in 1995?
Ensure brevity in your answer.  1.19. What is the ratio of the Aid flow from UN agencies (US$) of Pakistan in 1994 to that in 1995?
Your answer should be compact. 10.84. What is the ratio of the Aid flow from UN agencies (US$) in Senegal in 1994 to that in 1995?
Provide a succinct answer. 0.51. What is the ratio of the Aid flow from UN agencies (US$) in Sub-Saharan Africa (developing only) in 1994 to that in 1996?
Keep it short and to the point. 3.54. What is the ratio of the Aid flow from UN agencies (US$) of Guinea-Bissau in 1994 to that in 1996?
Offer a very short reply. 0.63. What is the ratio of the Aid flow from UN agencies (US$) in Pakistan in 1994 to that in 1996?
Your answer should be compact. 11.63. What is the ratio of the Aid flow from UN agencies (US$) of Sub-Saharan Africa (developing only) in 1994 to that in 1997?
Give a very brief answer. 8.78. What is the ratio of the Aid flow from UN agencies (US$) in Guinea-Bissau in 1994 to that in 1997?
Your answer should be very brief. 1.24. What is the ratio of the Aid flow from UN agencies (US$) in Pakistan in 1994 to that in 1997?
Give a very brief answer. 2.68. What is the ratio of the Aid flow from UN agencies (US$) of Senegal in 1994 to that in 1997?
Give a very brief answer. 1.25. What is the ratio of the Aid flow from UN agencies (US$) of Sub-Saharan Africa (developing only) in 1994 to that in 1998?
Make the answer very short. 6.46. What is the ratio of the Aid flow from UN agencies (US$) in Guinea-Bissau in 1994 to that in 1998?
Your response must be concise. 2.22. What is the ratio of the Aid flow from UN agencies (US$) of Pakistan in 1994 to that in 1998?
Your response must be concise. 4.16. What is the ratio of the Aid flow from UN agencies (US$) in Senegal in 1994 to that in 1998?
Give a very brief answer. 1.21. What is the ratio of the Aid flow from UN agencies (US$) in Sub-Saharan Africa (developing only) in 1994 to that in 1999?
Ensure brevity in your answer.  4.31. What is the ratio of the Aid flow from UN agencies (US$) in Guinea-Bissau in 1994 to that in 1999?
Make the answer very short. 4.93. What is the ratio of the Aid flow from UN agencies (US$) of Pakistan in 1994 to that in 1999?
Your answer should be compact. 3.67. What is the ratio of the Aid flow from UN agencies (US$) of Senegal in 1994 to that in 1999?
Provide a short and direct response. 0.78. What is the ratio of the Aid flow from UN agencies (US$) in Sub-Saharan Africa (developing only) in 1995 to that in 1996?
Provide a short and direct response. 2.85. What is the ratio of the Aid flow from UN agencies (US$) in Guinea-Bissau in 1995 to that in 1996?
Offer a terse response. 0.52. What is the ratio of the Aid flow from UN agencies (US$) of Pakistan in 1995 to that in 1996?
Your answer should be compact. 1.07. What is the ratio of the Aid flow from UN agencies (US$) in Senegal in 1995 to that in 1996?
Keep it short and to the point. 3.93. What is the ratio of the Aid flow from UN agencies (US$) of Sub-Saharan Africa (developing only) in 1995 to that in 1997?
Your response must be concise. 7.08. What is the ratio of the Aid flow from UN agencies (US$) in Guinea-Bissau in 1995 to that in 1997?
Offer a terse response. 1.04. What is the ratio of the Aid flow from UN agencies (US$) of Pakistan in 1995 to that in 1997?
Provide a short and direct response. 0.25. What is the ratio of the Aid flow from UN agencies (US$) of Senegal in 1995 to that in 1997?
Offer a terse response. 2.45. What is the ratio of the Aid flow from UN agencies (US$) of Sub-Saharan Africa (developing only) in 1995 to that in 1998?
Your response must be concise. 5.21. What is the ratio of the Aid flow from UN agencies (US$) of Guinea-Bissau in 1995 to that in 1998?
Your answer should be compact. 1.86. What is the ratio of the Aid flow from UN agencies (US$) in Pakistan in 1995 to that in 1998?
Provide a short and direct response. 0.38. What is the ratio of the Aid flow from UN agencies (US$) in Senegal in 1995 to that in 1998?
Keep it short and to the point. 2.38. What is the ratio of the Aid flow from UN agencies (US$) of Sub-Saharan Africa (developing only) in 1995 to that in 1999?
Your answer should be very brief. 3.48. What is the ratio of the Aid flow from UN agencies (US$) in Guinea-Bissau in 1995 to that in 1999?
Provide a succinct answer. 4.13. What is the ratio of the Aid flow from UN agencies (US$) of Pakistan in 1995 to that in 1999?
Your answer should be compact. 0.34. What is the ratio of the Aid flow from UN agencies (US$) of Senegal in 1995 to that in 1999?
Ensure brevity in your answer.  1.53. What is the ratio of the Aid flow from UN agencies (US$) in Sub-Saharan Africa (developing only) in 1996 to that in 1997?
Offer a very short reply. 2.48. What is the ratio of the Aid flow from UN agencies (US$) of Guinea-Bissau in 1996 to that in 1997?
Ensure brevity in your answer.  1.98. What is the ratio of the Aid flow from UN agencies (US$) of Pakistan in 1996 to that in 1997?
Make the answer very short. 0.23. What is the ratio of the Aid flow from UN agencies (US$) of Senegal in 1996 to that in 1997?
Give a very brief answer. 0.62. What is the ratio of the Aid flow from UN agencies (US$) in Sub-Saharan Africa (developing only) in 1996 to that in 1998?
Keep it short and to the point. 1.83. What is the ratio of the Aid flow from UN agencies (US$) in Guinea-Bissau in 1996 to that in 1998?
Offer a very short reply. 3.55. What is the ratio of the Aid flow from UN agencies (US$) of Pakistan in 1996 to that in 1998?
Make the answer very short. 0.36. What is the ratio of the Aid flow from UN agencies (US$) in Senegal in 1996 to that in 1998?
Offer a very short reply. 0.6. What is the ratio of the Aid flow from UN agencies (US$) in Sub-Saharan Africa (developing only) in 1996 to that in 1999?
Your answer should be compact. 1.22. What is the ratio of the Aid flow from UN agencies (US$) of Guinea-Bissau in 1996 to that in 1999?
Provide a short and direct response. 7.89. What is the ratio of the Aid flow from UN agencies (US$) in Pakistan in 1996 to that in 1999?
Keep it short and to the point. 0.32. What is the ratio of the Aid flow from UN agencies (US$) of Senegal in 1996 to that in 1999?
Your answer should be compact. 0.39. What is the ratio of the Aid flow from UN agencies (US$) of Sub-Saharan Africa (developing only) in 1997 to that in 1998?
Your answer should be very brief. 0.74. What is the ratio of the Aid flow from UN agencies (US$) of Guinea-Bissau in 1997 to that in 1998?
Make the answer very short. 1.79. What is the ratio of the Aid flow from UN agencies (US$) in Pakistan in 1997 to that in 1998?
Offer a very short reply. 1.55. What is the ratio of the Aid flow from UN agencies (US$) of Sub-Saharan Africa (developing only) in 1997 to that in 1999?
Ensure brevity in your answer.  0.49. What is the ratio of the Aid flow from UN agencies (US$) of Guinea-Bissau in 1997 to that in 1999?
Ensure brevity in your answer.  3.98. What is the ratio of the Aid flow from UN agencies (US$) in Pakistan in 1997 to that in 1999?
Ensure brevity in your answer.  1.37. What is the ratio of the Aid flow from UN agencies (US$) of Senegal in 1997 to that in 1999?
Keep it short and to the point. 0.62. What is the ratio of the Aid flow from UN agencies (US$) of Sub-Saharan Africa (developing only) in 1998 to that in 1999?
Offer a very short reply. 0.67. What is the ratio of the Aid flow from UN agencies (US$) of Guinea-Bissau in 1998 to that in 1999?
Offer a terse response. 2.22. What is the ratio of the Aid flow from UN agencies (US$) in Pakistan in 1998 to that in 1999?
Keep it short and to the point. 0.88. What is the ratio of the Aid flow from UN agencies (US$) in Senegal in 1998 to that in 1999?
Give a very brief answer. 0.64. What is the difference between the highest and the second highest Aid flow from UN agencies (US$) of Sub-Saharan Africa (developing only)?
Make the answer very short. 1.47e+08. What is the difference between the highest and the second highest Aid flow from UN agencies (US$) in Guinea-Bissau?
Your response must be concise. 1.33e+06. What is the difference between the highest and the second highest Aid flow from UN agencies (US$) in Pakistan?
Your answer should be very brief. 2.21e+07. What is the difference between the highest and the second highest Aid flow from UN agencies (US$) in Senegal?
Make the answer very short. 2.06e+06. What is the difference between the highest and the lowest Aid flow from UN agencies (US$) of Sub-Saharan Africa (developing only)?
Your response must be concise. 6.71e+08. What is the difference between the highest and the lowest Aid flow from UN agencies (US$) of Guinea-Bissau?
Your answer should be very brief. 3.10e+06. What is the difference between the highest and the lowest Aid flow from UN agencies (US$) in Pakistan?
Provide a succinct answer. 3.22e+07. What is the difference between the highest and the lowest Aid flow from UN agencies (US$) in Senegal?
Your response must be concise. 4.43e+06. 